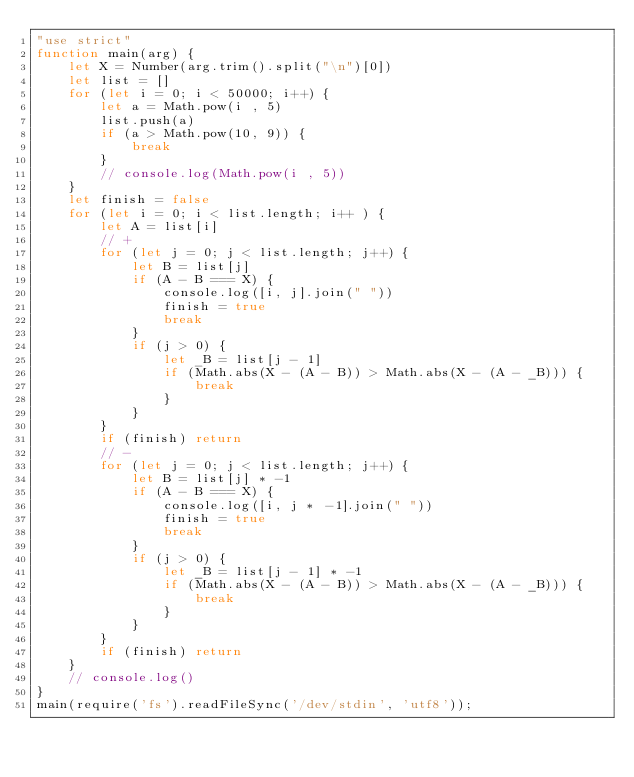<code> <loc_0><loc_0><loc_500><loc_500><_JavaScript_>"use strict"
function main(arg) {
    let X = Number(arg.trim().split("\n")[0])
    let list = []
    for (let i = 0; i < 50000; i++) {
        let a = Math.pow(i , 5)
        list.push(a)
        if (a > Math.pow(10, 9)) {
            break
        }
        // console.log(Math.pow(i , 5))
    }
    let finish = false
    for (let i = 0; i < list.length; i++ ) {
        let A = list[i]
        // +
        for (let j = 0; j < list.length; j++) {
            let B = list[j]
            if (A - B === X) {
                console.log([i, j].join(" "))
                finish = true
                break
            }
            if (j > 0) {
                let _B = list[j - 1]
                if (Math.abs(X - (A - B)) > Math.abs(X - (A - _B))) {
                    break
                }
            }
        }
        if (finish) return
        // -
        for (let j = 0; j < list.length; j++) {
            let B = list[j] * -1
            if (A - B === X) {
                console.log([i, j * -1].join(" "))
                finish = true
                break
            }
            if (j > 0) {
                let _B = list[j - 1] * -1
                if (Math.abs(X - (A - B)) > Math.abs(X - (A - _B))) {
                    break
                }
            }
        }
        if (finish) return
    }
    // console.log()
}
main(require('fs').readFileSync('/dev/stdin', 'utf8'));</code> 